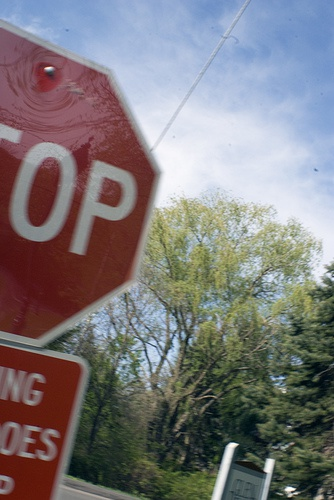Describe the objects in this image and their specific colors. I can see a stop sign in darkgray, maroon, and brown tones in this image. 